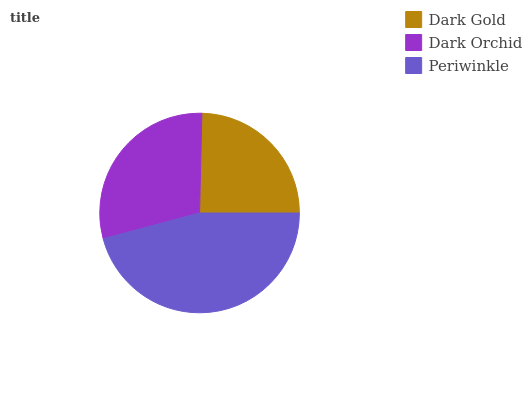Is Dark Gold the minimum?
Answer yes or no. Yes. Is Periwinkle the maximum?
Answer yes or no. Yes. Is Dark Orchid the minimum?
Answer yes or no. No. Is Dark Orchid the maximum?
Answer yes or no. No. Is Dark Orchid greater than Dark Gold?
Answer yes or no. Yes. Is Dark Gold less than Dark Orchid?
Answer yes or no. Yes. Is Dark Gold greater than Dark Orchid?
Answer yes or no. No. Is Dark Orchid less than Dark Gold?
Answer yes or no. No. Is Dark Orchid the high median?
Answer yes or no. Yes. Is Dark Orchid the low median?
Answer yes or no. Yes. Is Dark Gold the high median?
Answer yes or no. No. Is Periwinkle the low median?
Answer yes or no. No. 